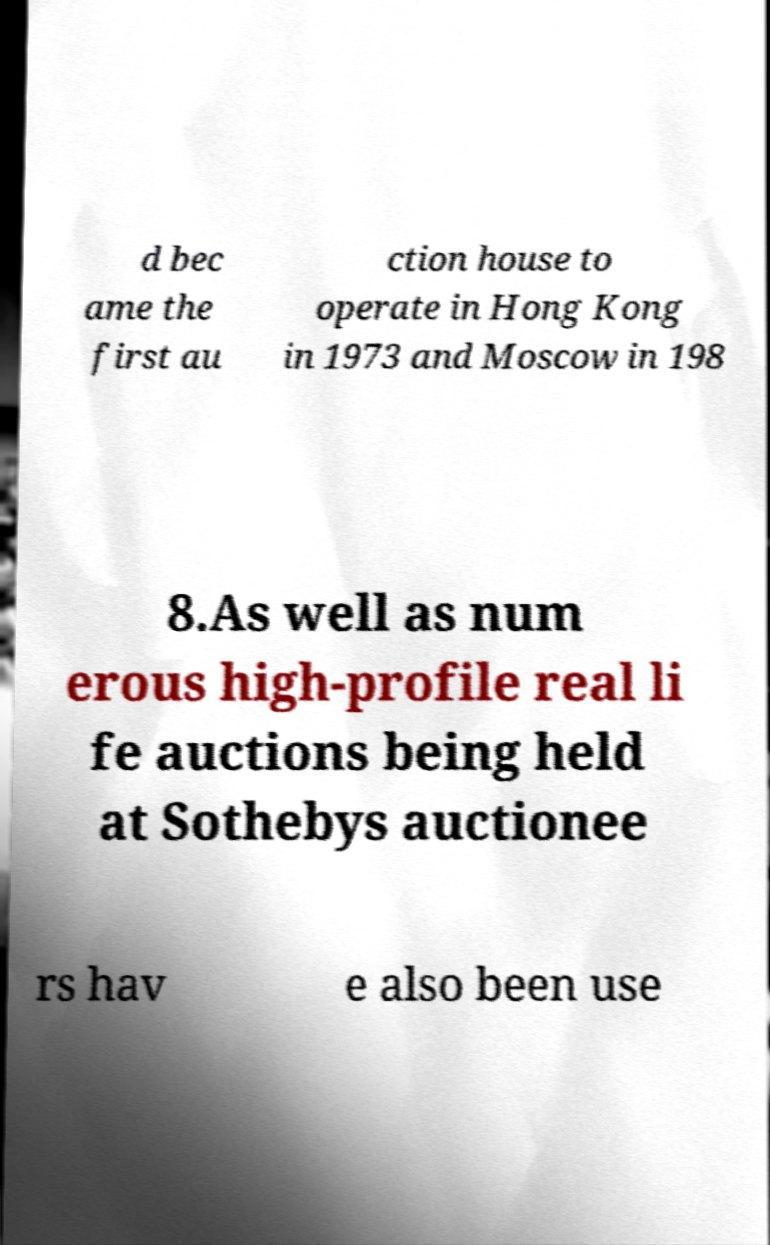Could you assist in decoding the text presented in this image and type it out clearly? d bec ame the first au ction house to operate in Hong Kong in 1973 and Moscow in 198 8.As well as num erous high-profile real li fe auctions being held at Sothebys auctionee rs hav e also been use 